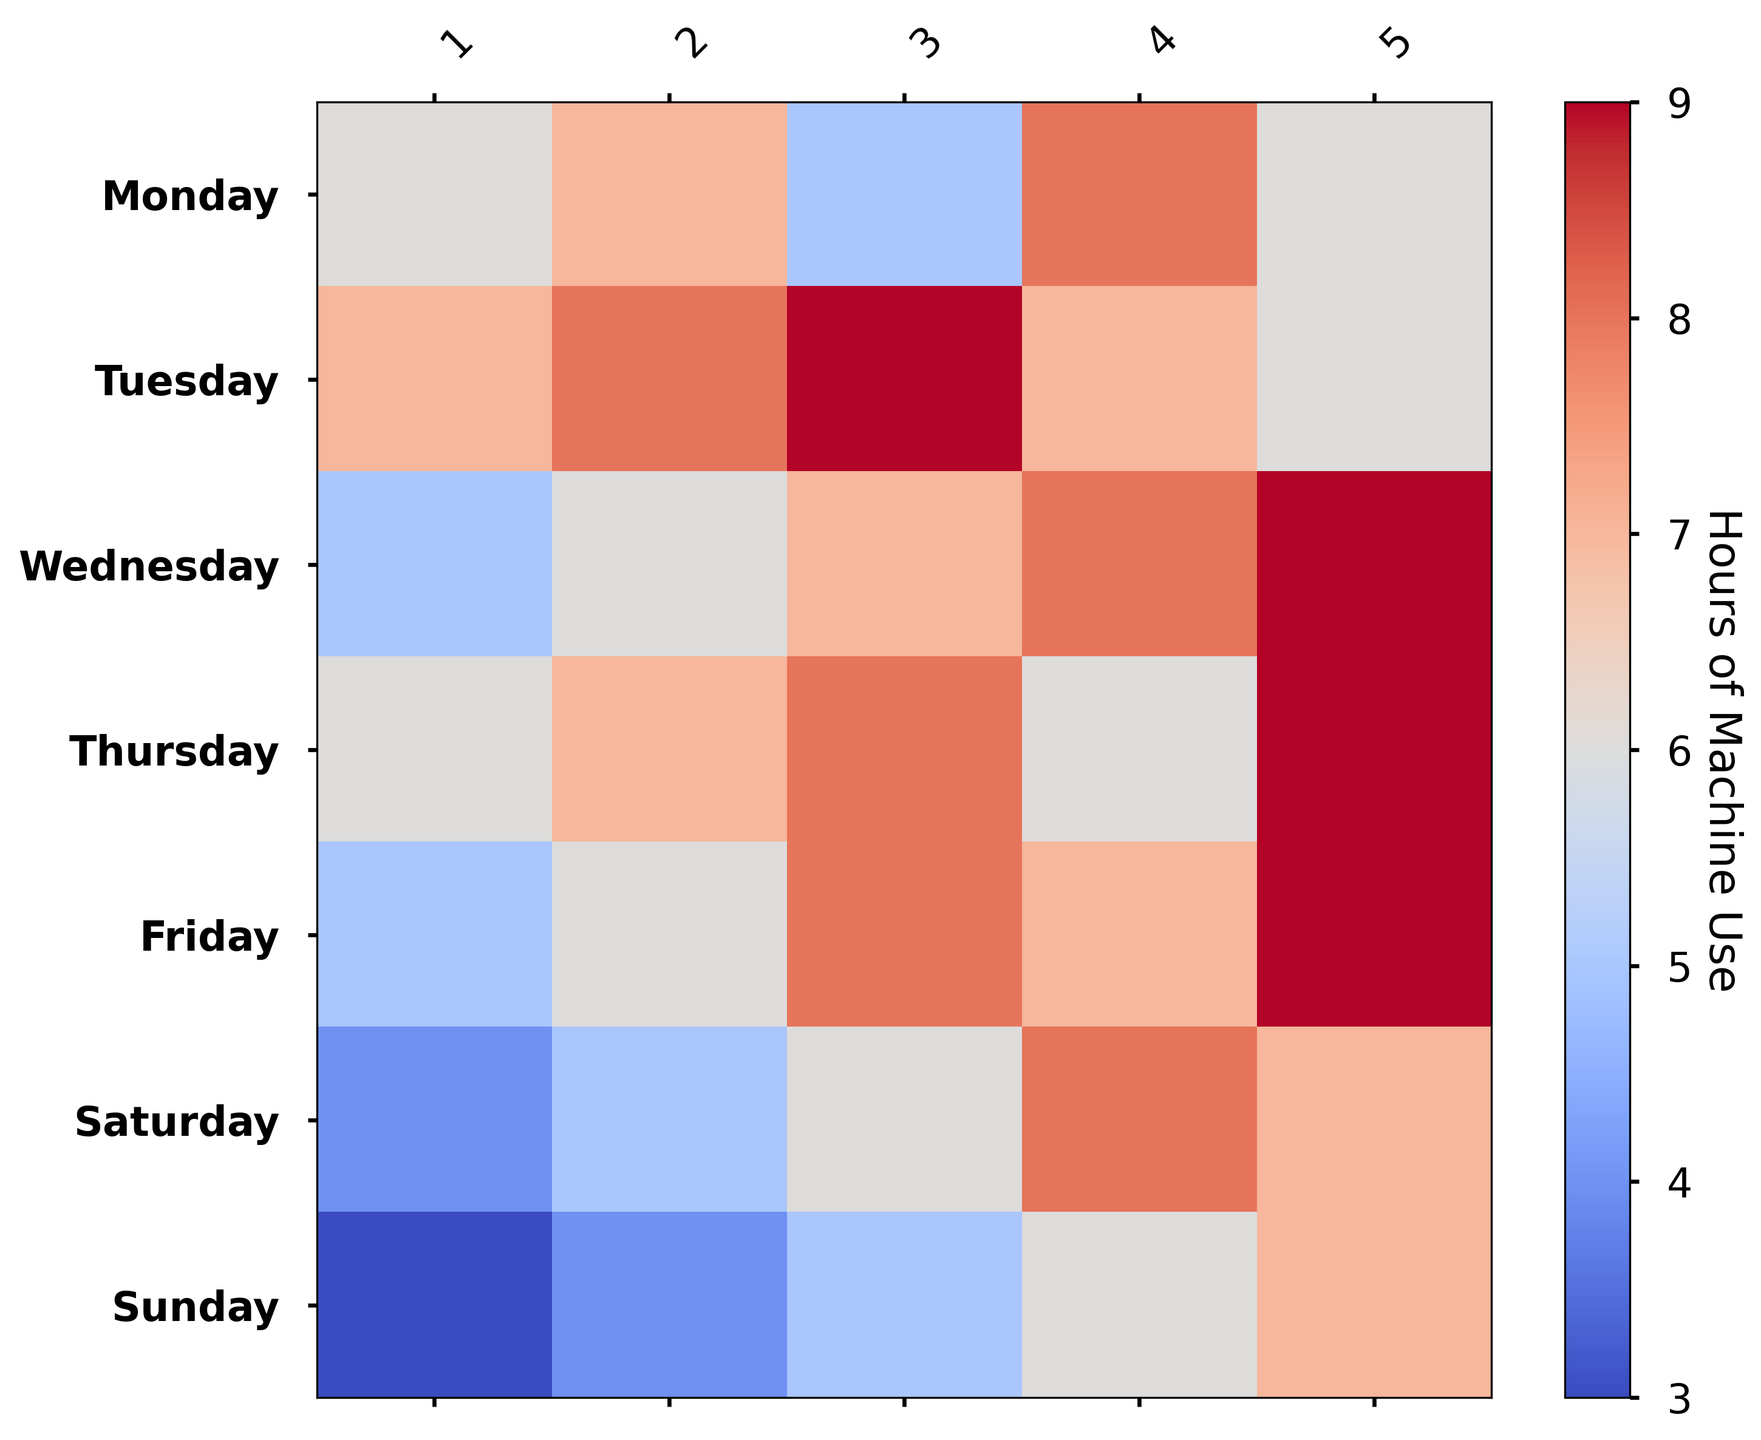What is the day with the lowest average hours of machine use? Scan the figure for the day with the lightest color, indicating the lowest usage. Sunday appears to have the lightest hues. Sunday
Answer: Sunday Which day has the most consistent machine use? Review the color variance across each day; the day with the most uniform color intensity across columns has the most consistent use. Tuesday shows relatively consistent colors.
Answer: Tuesday On which day is the peak machine usage higher: Monday or Friday? Look at the color intensity for both Monday and Friday. The darkest hues indicate peak usage. Both days have dark squares, but Friday has darker shades.
Answer: Friday What is the combined average usage for Wednesday and Thursday? Note the color intensities for Wednesday and Thursday, sum their average usages, and divide by two. Wednesday generally shows darker hues, so the combined average is weighted more towards high usage. Rough calculation: (7+8)/2.
Answer: ~7.5 Which days show the highest variability in machine usage? Identify days with the most varied colors ranging from light to dark; these indicate high variability. Saturday and Sunday show much more variability in colors.
Answer: Saturday, Sunday Compare the average machine usages on weekends vs weekdays. Which is higher? Observe the general color intensity for weekdays (Monday-Friday) and weekends (Saturday-Sunday). Weekdays show generally darker hues compared to weekends' lighter hues.
Answer: Weekdays What is the difference between the highest usage day and the lowest usage day? Identify the darkest color block (highest usage) and lightest color block (lowest usage). Highest usage is ~9 (Friday), lowest ~3 (Sunday). Difference: 9-3.
Answer: 6 Is there any day where machine use exceeds 8 hours consistently? Look for columns entirely shaded with dark hues on a single day. No single day has all columns exceeding 8 hours consistently.
Answer: No On which day is the least machine utilization recorded? Search for the lightest color block across all days. The lightest color is seen on Sunday.
Answer: Sunday What is the trend of machine use from Monday to Sunday? Observe the change in hue from Monday to Sunday to infer if the usage increases or decreases. The colors generally start dark and lighten towards the weekend.
Answer: Decreasing 